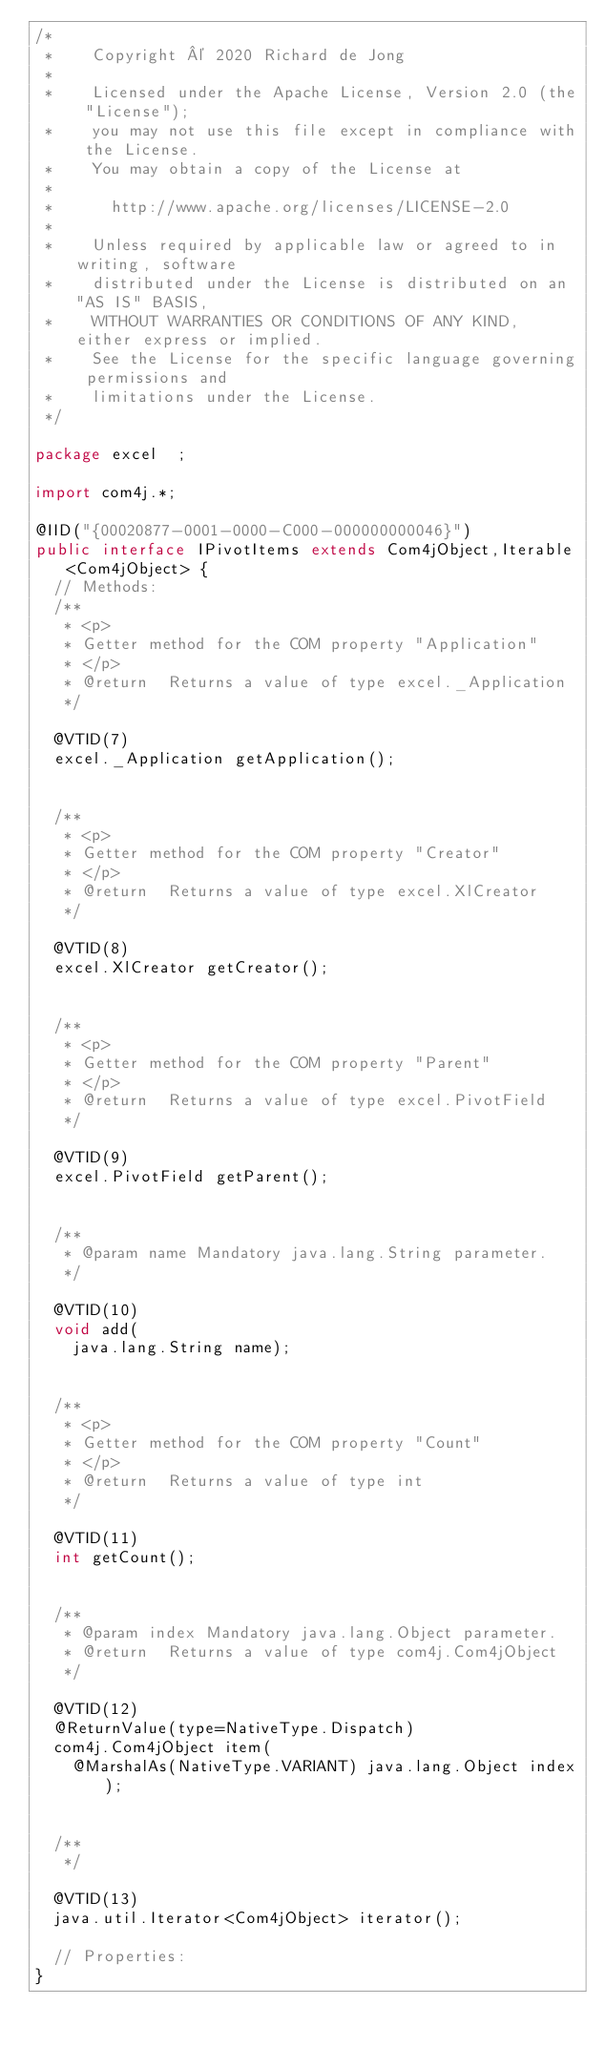<code> <loc_0><loc_0><loc_500><loc_500><_Java_>/*
 *    Copyright © 2020 Richard de Jong
 *
 *    Licensed under the Apache License, Version 2.0 (the "License");
 *    you may not use this file except in compliance with the License.
 *    You may obtain a copy of the License at
 *
 *      http://www.apache.org/licenses/LICENSE-2.0
 *
 *    Unless required by applicable law or agreed to in writing, software
 *    distributed under the License is distributed on an "AS IS" BASIS,
 *    WITHOUT WARRANTIES OR CONDITIONS OF ANY KIND, either express or implied.
 *    See the License for the specific language governing permissions and
 *    limitations under the License.
 */

package excel  ;

import com4j.*;

@IID("{00020877-0001-0000-C000-000000000046}")
public interface IPivotItems extends Com4jObject,Iterable<Com4jObject> {
  // Methods:
  /**
   * <p>
   * Getter method for the COM property "Application"
   * </p>
   * @return  Returns a value of type excel._Application
   */

  @VTID(7)
  excel._Application getApplication();


  /**
   * <p>
   * Getter method for the COM property "Creator"
   * </p>
   * @return  Returns a value of type excel.XlCreator
   */

  @VTID(8)
  excel.XlCreator getCreator();


  /**
   * <p>
   * Getter method for the COM property "Parent"
   * </p>
   * @return  Returns a value of type excel.PivotField
   */

  @VTID(9)
  excel.PivotField getParent();


  /**
   * @param name Mandatory java.lang.String parameter.
   */

  @VTID(10)
  void add(
    java.lang.String name);


  /**
   * <p>
   * Getter method for the COM property "Count"
   * </p>
   * @return  Returns a value of type int
   */

  @VTID(11)
  int getCount();


  /**
   * @param index Mandatory java.lang.Object parameter.
   * @return  Returns a value of type com4j.Com4jObject
   */

  @VTID(12)
  @ReturnValue(type=NativeType.Dispatch)
  com4j.Com4jObject item(
    @MarshalAs(NativeType.VARIANT) java.lang.Object index);


  /**
   */

  @VTID(13)
  java.util.Iterator<Com4jObject> iterator();

  // Properties:
}
</code> 